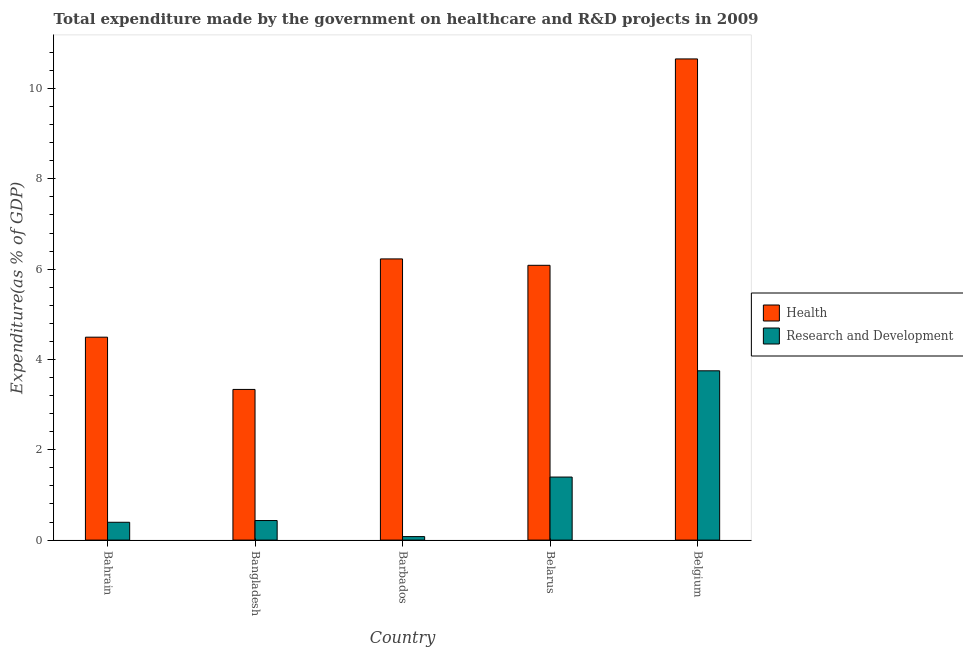How many bars are there on the 4th tick from the right?
Your answer should be very brief. 2. What is the expenditure in r&d in Barbados?
Give a very brief answer. 0.08. Across all countries, what is the maximum expenditure in healthcare?
Keep it short and to the point. 10.65. Across all countries, what is the minimum expenditure in r&d?
Offer a terse response. 0.08. In which country was the expenditure in r&d maximum?
Ensure brevity in your answer.  Belgium. What is the total expenditure in r&d in the graph?
Give a very brief answer. 6.05. What is the difference between the expenditure in r&d in Bangladesh and that in Belarus?
Keep it short and to the point. -0.96. What is the difference between the expenditure in r&d in Bahrain and the expenditure in healthcare in Belarus?
Your response must be concise. -5.69. What is the average expenditure in r&d per country?
Your answer should be compact. 1.21. What is the difference between the expenditure in r&d and expenditure in healthcare in Belgium?
Your response must be concise. -6.91. What is the ratio of the expenditure in r&d in Bangladesh to that in Belarus?
Your answer should be compact. 0.31. Is the difference between the expenditure in r&d in Bangladesh and Belarus greater than the difference between the expenditure in healthcare in Bangladesh and Belarus?
Your answer should be compact. Yes. What is the difference between the highest and the second highest expenditure in healthcare?
Provide a short and direct response. 4.43. What is the difference between the highest and the lowest expenditure in healthcare?
Provide a succinct answer. 7.32. In how many countries, is the expenditure in r&d greater than the average expenditure in r&d taken over all countries?
Provide a short and direct response. 2. What does the 2nd bar from the left in Belgium represents?
Offer a terse response. Research and Development. What does the 2nd bar from the right in Bahrain represents?
Your answer should be compact. Health. Are all the bars in the graph horizontal?
Keep it short and to the point. No. Are the values on the major ticks of Y-axis written in scientific E-notation?
Offer a very short reply. No. Does the graph contain any zero values?
Ensure brevity in your answer.  No. Does the graph contain grids?
Provide a short and direct response. No. Where does the legend appear in the graph?
Offer a terse response. Center right. How many legend labels are there?
Provide a succinct answer. 2. What is the title of the graph?
Give a very brief answer. Total expenditure made by the government on healthcare and R&D projects in 2009. What is the label or title of the Y-axis?
Offer a terse response. Expenditure(as % of GDP). What is the Expenditure(as % of GDP) in Health in Bahrain?
Ensure brevity in your answer.  4.49. What is the Expenditure(as % of GDP) in Research and Development in Bahrain?
Your answer should be very brief. 0.39. What is the Expenditure(as % of GDP) of Health in Bangladesh?
Your answer should be very brief. 3.34. What is the Expenditure(as % of GDP) of Research and Development in Bangladesh?
Offer a very short reply. 0.43. What is the Expenditure(as % of GDP) in Health in Barbados?
Your answer should be compact. 6.23. What is the Expenditure(as % of GDP) of Research and Development in Barbados?
Your answer should be compact. 0.08. What is the Expenditure(as % of GDP) of Health in Belarus?
Provide a succinct answer. 6.09. What is the Expenditure(as % of GDP) of Research and Development in Belarus?
Offer a terse response. 1.4. What is the Expenditure(as % of GDP) in Health in Belgium?
Give a very brief answer. 10.65. What is the Expenditure(as % of GDP) in Research and Development in Belgium?
Make the answer very short. 3.75. Across all countries, what is the maximum Expenditure(as % of GDP) in Health?
Your answer should be compact. 10.65. Across all countries, what is the maximum Expenditure(as % of GDP) of Research and Development?
Provide a short and direct response. 3.75. Across all countries, what is the minimum Expenditure(as % of GDP) of Health?
Make the answer very short. 3.34. Across all countries, what is the minimum Expenditure(as % of GDP) in Research and Development?
Offer a very short reply. 0.08. What is the total Expenditure(as % of GDP) of Health in the graph?
Make the answer very short. 30.8. What is the total Expenditure(as % of GDP) of Research and Development in the graph?
Make the answer very short. 6.05. What is the difference between the Expenditure(as % of GDP) of Health in Bahrain and that in Bangladesh?
Keep it short and to the point. 1.16. What is the difference between the Expenditure(as % of GDP) of Research and Development in Bahrain and that in Bangladesh?
Keep it short and to the point. -0.04. What is the difference between the Expenditure(as % of GDP) in Health in Bahrain and that in Barbados?
Your answer should be compact. -1.73. What is the difference between the Expenditure(as % of GDP) of Research and Development in Bahrain and that in Barbados?
Your answer should be very brief. 0.32. What is the difference between the Expenditure(as % of GDP) of Health in Bahrain and that in Belarus?
Provide a short and direct response. -1.59. What is the difference between the Expenditure(as % of GDP) in Research and Development in Bahrain and that in Belarus?
Give a very brief answer. -1. What is the difference between the Expenditure(as % of GDP) in Health in Bahrain and that in Belgium?
Ensure brevity in your answer.  -6.16. What is the difference between the Expenditure(as % of GDP) in Research and Development in Bahrain and that in Belgium?
Give a very brief answer. -3.35. What is the difference between the Expenditure(as % of GDP) of Health in Bangladesh and that in Barbados?
Provide a succinct answer. -2.89. What is the difference between the Expenditure(as % of GDP) of Research and Development in Bangladesh and that in Barbados?
Provide a short and direct response. 0.36. What is the difference between the Expenditure(as % of GDP) of Health in Bangladesh and that in Belarus?
Make the answer very short. -2.75. What is the difference between the Expenditure(as % of GDP) of Research and Development in Bangladesh and that in Belarus?
Ensure brevity in your answer.  -0.96. What is the difference between the Expenditure(as % of GDP) of Health in Bangladesh and that in Belgium?
Keep it short and to the point. -7.32. What is the difference between the Expenditure(as % of GDP) of Research and Development in Bangladesh and that in Belgium?
Offer a very short reply. -3.32. What is the difference between the Expenditure(as % of GDP) of Health in Barbados and that in Belarus?
Give a very brief answer. 0.14. What is the difference between the Expenditure(as % of GDP) in Research and Development in Barbados and that in Belarus?
Offer a very short reply. -1.32. What is the difference between the Expenditure(as % of GDP) in Health in Barbados and that in Belgium?
Offer a terse response. -4.43. What is the difference between the Expenditure(as % of GDP) in Research and Development in Barbados and that in Belgium?
Keep it short and to the point. -3.67. What is the difference between the Expenditure(as % of GDP) of Health in Belarus and that in Belgium?
Give a very brief answer. -4.57. What is the difference between the Expenditure(as % of GDP) in Research and Development in Belarus and that in Belgium?
Your answer should be compact. -2.35. What is the difference between the Expenditure(as % of GDP) in Health in Bahrain and the Expenditure(as % of GDP) in Research and Development in Bangladesh?
Ensure brevity in your answer.  4.06. What is the difference between the Expenditure(as % of GDP) in Health in Bahrain and the Expenditure(as % of GDP) in Research and Development in Barbados?
Ensure brevity in your answer.  4.42. What is the difference between the Expenditure(as % of GDP) of Health in Bahrain and the Expenditure(as % of GDP) of Research and Development in Belarus?
Offer a very short reply. 3.1. What is the difference between the Expenditure(as % of GDP) of Health in Bahrain and the Expenditure(as % of GDP) of Research and Development in Belgium?
Keep it short and to the point. 0.74. What is the difference between the Expenditure(as % of GDP) in Health in Bangladesh and the Expenditure(as % of GDP) in Research and Development in Barbados?
Offer a terse response. 3.26. What is the difference between the Expenditure(as % of GDP) in Health in Bangladesh and the Expenditure(as % of GDP) in Research and Development in Belarus?
Give a very brief answer. 1.94. What is the difference between the Expenditure(as % of GDP) in Health in Bangladesh and the Expenditure(as % of GDP) in Research and Development in Belgium?
Provide a short and direct response. -0.41. What is the difference between the Expenditure(as % of GDP) of Health in Barbados and the Expenditure(as % of GDP) of Research and Development in Belarus?
Make the answer very short. 4.83. What is the difference between the Expenditure(as % of GDP) in Health in Barbados and the Expenditure(as % of GDP) in Research and Development in Belgium?
Make the answer very short. 2.48. What is the difference between the Expenditure(as % of GDP) in Health in Belarus and the Expenditure(as % of GDP) in Research and Development in Belgium?
Offer a very short reply. 2.34. What is the average Expenditure(as % of GDP) of Health per country?
Ensure brevity in your answer.  6.16. What is the average Expenditure(as % of GDP) of Research and Development per country?
Your answer should be compact. 1.21. What is the difference between the Expenditure(as % of GDP) of Health and Expenditure(as % of GDP) of Research and Development in Bahrain?
Your answer should be compact. 4.1. What is the difference between the Expenditure(as % of GDP) in Health and Expenditure(as % of GDP) in Research and Development in Bangladesh?
Provide a succinct answer. 2.9. What is the difference between the Expenditure(as % of GDP) of Health and Expenditure(as % of GDP) of Research and Development in Barbados?
Provide a succinct answer. 6.15. What is the difference between the Expenditure(as % of GDP) in Health and Expenditure(as % of GDP) in Research and Development in Belarus?
Provide a succinct answer. 4.69. What is the difference between the Expenditure(as % of GDP) of Health and Expenditure(as % of GDP) of Research and Development in Belgium?
Your answer should be very brief. 6.91. What is the ratio of the Expenditure(as % of GDP) in Health in Bahrain to that in Bangladesh?
Ensure brevity in your answer.  1.35. What is the ratio of the Expenditure(as % of GDP) of Research and Development in Bahrain to that in Bangladesh?
Give a very brief answer. 0.91. What is the ratio of the Expenditure(as % of GDP) in Health in Bahrain to that in Barbados?
Make the answer very short. 0.72. What is the ratio of the Expenditure(as % of GDP) in Research and Development in Bahrain to that in Barbados?
Keep it short and to the point. 5.1. What is the ratio of the Expenditure(as % of GDP) in Health in Bahrain to that in Belarus?
Ensure brevity in your answer.  0.74. What is the ratio of the Expenditure(as % of GDP) of Research and Development in Bahrain to that in Belarus?
Ensure brevity in your answer.  0.28. What is the ratio of the Expenditure(as % of GDP) of Health in Bahrain to that in Belgium?
Your answer should be compact. 0.42. What is the ratio of the Expenditure(as % of GDP) of Research and Development in Bahrain to that in Belgium?
Keep it short and to the point. 0.11. What is the ratio of the Expenditure(as % of GDP) in Health in Bangladesh to that in Barbados?
Your response must be concise. 0.54. What is the ratio of the Expenditure(as % of GDP) in Research and Development in Bangladesh to that in Barbados?
Your answer should be compact. 5.59. What is the ratio of the Expenditure(as % of GDP) of Health in Bangladesh to that in Belarus?
Keep it short and to the point. 0.55. What is the ratio of the Expenditure(as % of GDP) of Research and Development in Bangladesh to that in Belarus?
Your answer should be very brief. 0.31. What is the ratio of the Expenditure(as % of GDP) in Health in Bangladesh to that in Belgium?
Keep it short and to the point. 0.31. What is the ratio of the Expenditure(as % of GDP) of Research and Development in Bangladesh to that in Belgium?
Your answer should be very brief. 0.12. What is the ratio of the Expenditure(as % of GDP) in Health in Barbados to that in Belarus?
Give a very brief answer. 1.02. What is the ratio of the Expenditure(as % of GDP) of Research and Development in Barbados to that in Belarus?
Ensure brevity in your answer.  0.06. What is the ratio of the Expenditure(as % of GDP) of Health in Barbados to that in Belgium?
Make the answer very short. 0.58. What is the ratio of the Expenditure(as % of GDP) in Research and Development in Barbados to that in Belgium?
Your response must be concise. 0.02. What is the ratio of the Expenditure(as % of GDP) of Health in Belarus to that in Belgium?
Give a very brief answer. 0.57. What is the ratio of the Expenditure(as % of GDP) of Research and Development in Belarus to that in Belgium?
Provide a short and direct response. 0.37. What is the difference between the highest and the second highest Expenditure(as % of GDP) in Health?
Offer a terse response. 4.43. What is the difference between the highest and the second highest Expenditure(as % of GDP) of Research and Development?
Ensure brevity in your answer.  2.35. What is the difference between the highest and the lowest Expenditure(as % of GDP) of Health?
Provide a succinct answer. 7.32. What is the difference between the highest and the lowest Expenditure(as % of GDP) of Research and Development?
Your answer should be compact. 3.67. 